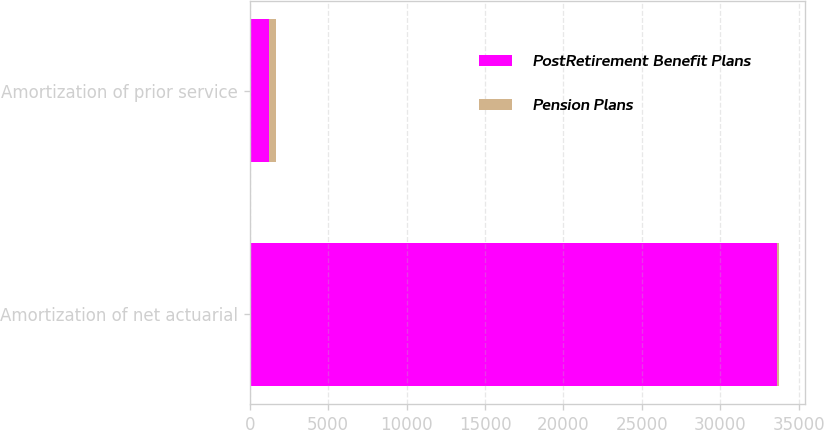Convert chart to OTSL. <chart><loc_0><loc_0><loc_500><loc_500><stacked_bar_chart><ecel><fcel>Amortization of net actuarial<fcel>Amortization of prior service<nl><fcel>PostRetirement Benefit Plans<fcel>33630<fcel>1202<nl><fcel>Pension Plans<fcel>114<fcel>475<nl></chart> 